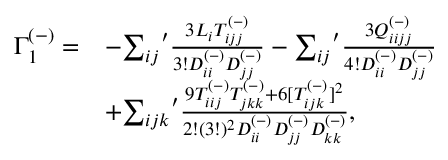Convert formula to latex. <formula><loc_0><loc_0><loc_500><loc_500>\begin{array} { r l } { \Gamma _ { 1 } ^ { ( - ) } = } & { - { \sum _ { i j } } ^ { \prime } \frac { 3 L _ { i } T _ { i j j } ^ { ( - ) } } { 3 ! D _ { i i } ^ { ( - ) } D _ { j j } ^ { ( - ) } } - { \sum _ { i j } } ^ { \prime } \frac { 3 Q _ { i i j j } ^ { ( - ) } } { 4 ! D _ { i i } ^ { ( - ) } D _ { j j } ^ { ( - ) } } } \\ & { + { \sum _ { i j k } } ^ { \prime } \frac { 9 T _ { i i j } ^ { ( - ) } T _ { j k k } ^ { ( - ) } + 6 [ T _ { i j k } ^ { ( - ) } ] ^ { 2 } } { 2 ! ( 3 ! ) ^ { 2 } D _ { i i } ^ { ( - ) } D _ { j j } ^ { ( - ) } D _ { k k } ^ { ( - ) } } , } \end{array}</formula> 